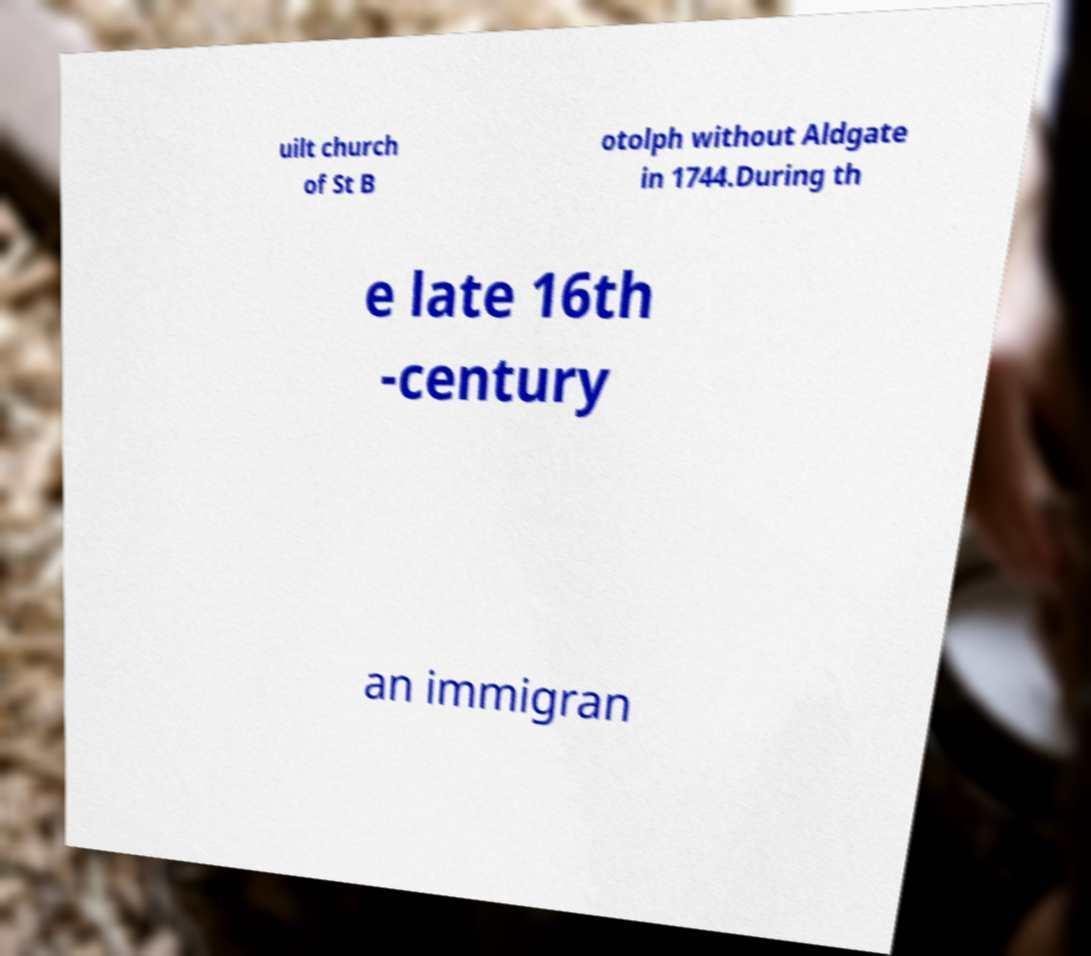Please identify and transcribe the text found in this image. uilt church of St B otolph without Aldgate in 1744.During th e late 16th -century an immigran 